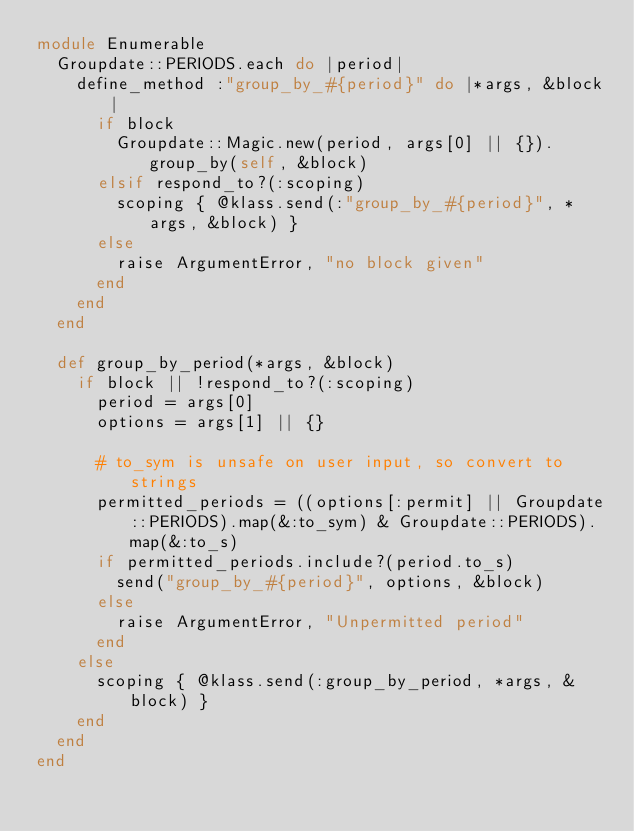<code> <loc_0><loc_0><loc_500><loc_500><_Ruby_>module Enumerable
  Groupdate::PERIODS.each do |period|
    define_method :"group_by_#{period}" do |*args, &block|
      if block
        Groupdate::Magic.new(period, args[0] || {}).group_by(self, &block)
      elsif respond_to?(:scoping)
        scoping { @klass.send(:"group_by_#{period}", *args, &block) }
      else
        raise ArgumentError, "no block given"
      end
    end
  end

  def group_by_period(*args, &block)
    if block || !respond_to?(:scoping)
      period = args[0]
      options = args[1] || {}

      # to_sym is unsafe on user input, so convert to strings
      permitted_periods = ((options[:permit] || Groupdate::PERIODS).map(&:to_sym) & Groupdate::PERIODS).map(&:to_s)
      if permitted_periods.include?(period.to_s)
        send("group_by_#{period}", options, &block)
      else
        raise ArgumentError, "Unpermitted period"
      end
    else
      scoping { @klass.send(:group_by_period, *args, &block) }
    end
  end
end
</code> 